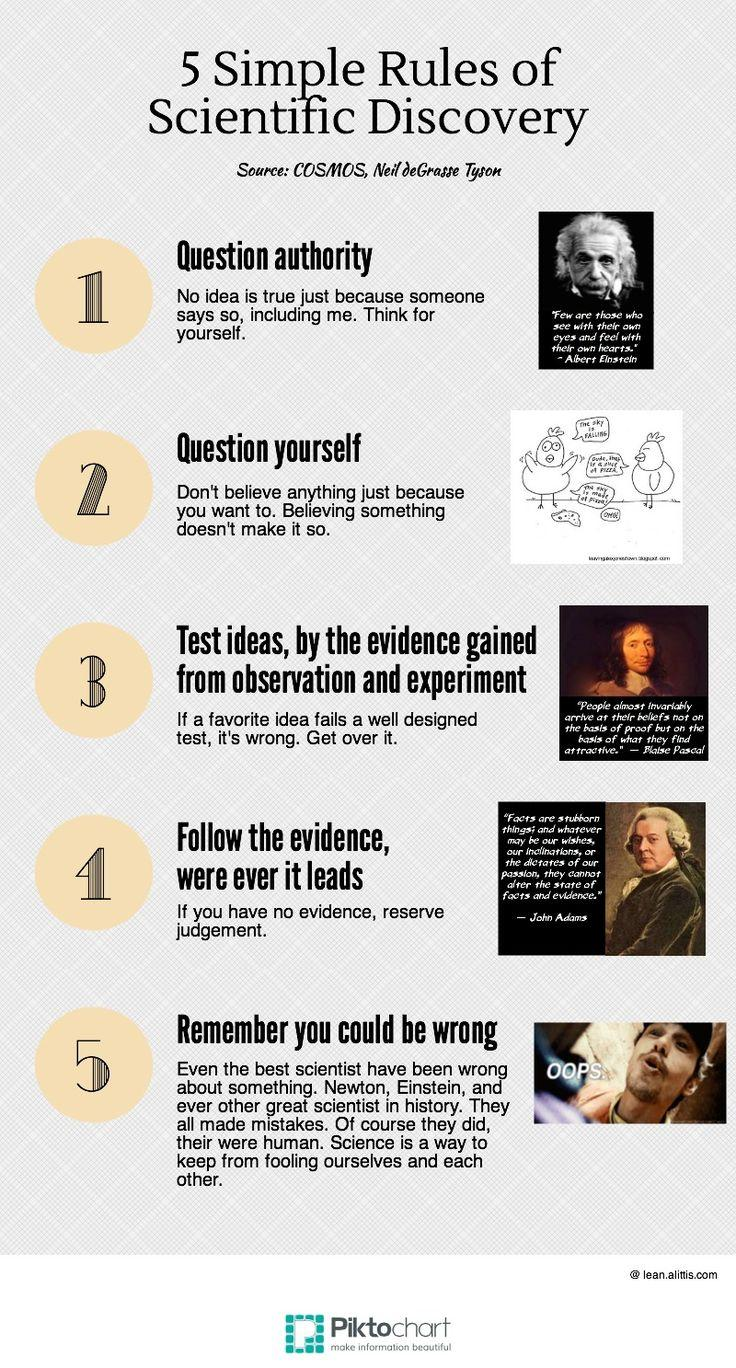Point out several critical features in this image. Blaise Pascal is the French mathematician whose image is displayed in the document, as indicated by the text. 